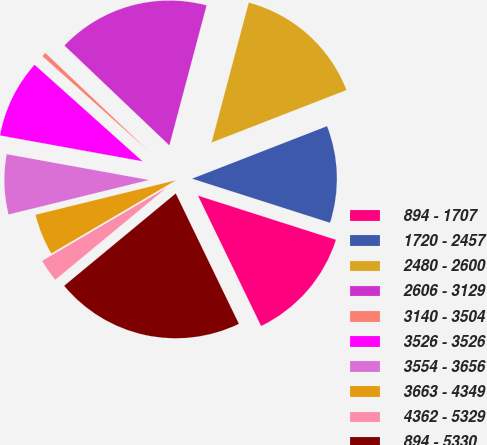Convert chart. <chart><loc_0><loc_0><loc_500><loc_500><pie_chart><fcel>894 - 1707<fcel>1720 - 2457<fcel>2480 - 2600<fcel>2606 - 3129<fcel>3140 - 3504<fcel>3526 - 3526<fcel>3554 - 3656<fcel>3663 - 4349<fcel>4362 - 5329<fcel>894 - 5330<nl><fcel>12.9%<fcel>10.83%<fcel>14.96%<fcel>17.03%<fcel>0.49%<fcel>8.76%<fcel>6.69%<fcel>4.62%<fcel>2.55%<fcel>21.17%<nl></chart> 